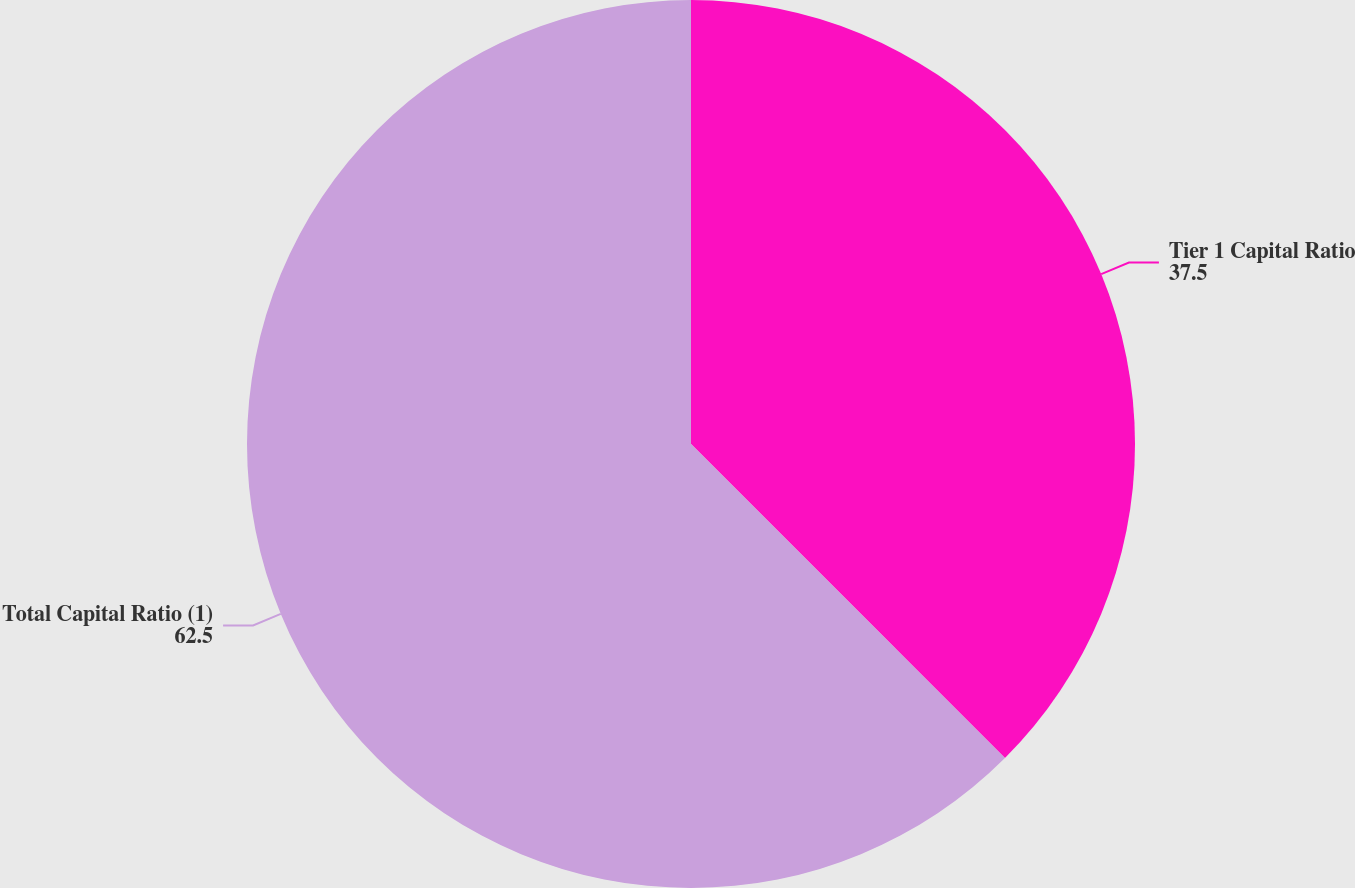<chart> <loc_0><loc_0><loc_500><loc_500><pie_chart><fcel>Tier 1 Capital Ratio<fcel>Total Capital Ratio (1)<nl><fcel>37.5%<fcel>62.5%<nl></chart> 